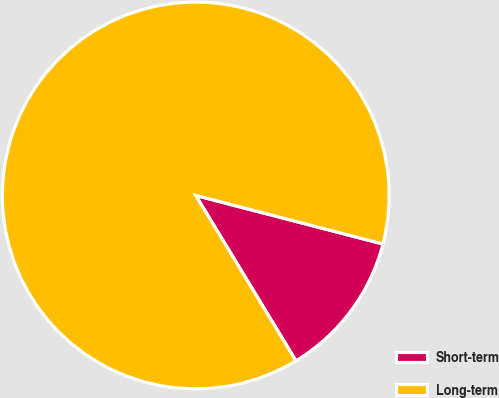Convert chart. <chart><loc_0><loc_0><loc_500><loc_500><pie_chart><fcel>Short-term<fcel>Long-term<nl><fcel>12.29%<fcel>87.71%<nl></chart> 